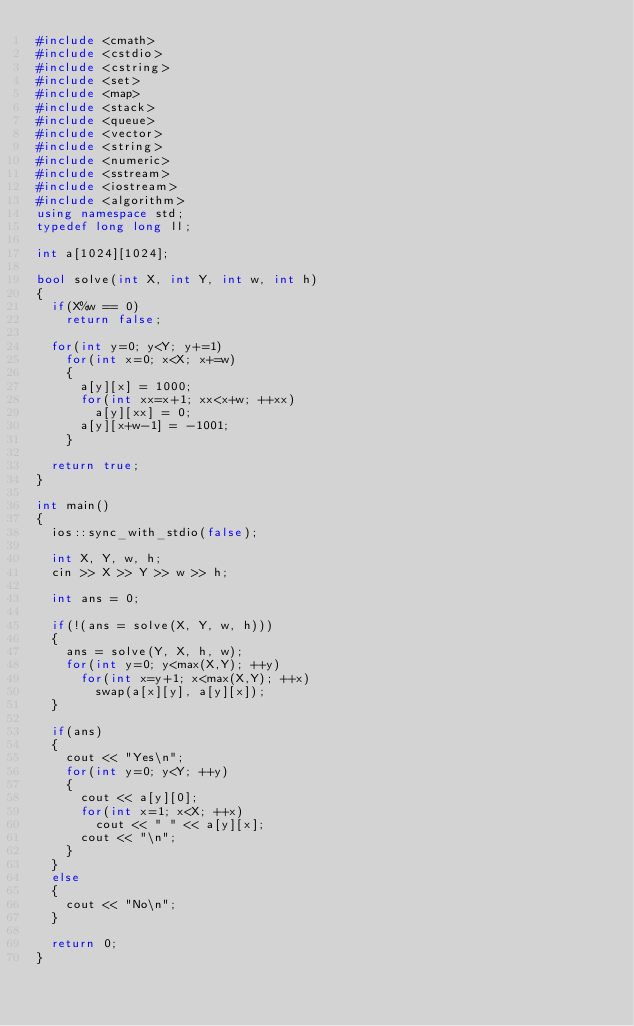<code> <loc_0><loc_0><loc_500><loc_500><_C++_>#include <cmath>
#include <cstdio>
#include <cstring>
#include <set>
#include <map>
#include <stack>
#include <queue>
#include <vector>
#include <string>
#include <numeric>
#include <sstream>
#include <iostream>
#include <algorithm>
using namespace std;
typedef long long ll;

int a[1024][1024];

bool solve(int X, int Y, int w, int h)
{
	if(X%w == 0)
		return false;
	
	for(int y=0; y<Y; y+=1)
		for(int x=0; x<X; x+=w)
		{
			a[y][x] = 1000;
			for(int xx=x+1; xx<x+w; ++xx)
				a[y][xx] = 0;
			a[y][x+w-1] = -1001;
		}
	
	return true;
}

int main()
{
	ios::sync_with_stdio(false);

	int X, Y, w, h;
	cin >> X >> Y >> w >> h;

	int ans = 0;
	
	if(!(ans = solve(X, Y, w, h)))
	{
		ans = solve(Y, X, h, w);
		for(int y=0; y<max(X,Y); ++y)
			for(int x=y+1; x<max(X,Y); ++x)
				swap(a[x][y], a[y][x]);
	}
	
	if(ans)
	{
		cout << "Yes\n";
		for(int y=0; y<Y; ++y)
		{
			cout << a[y][0];
			for(int x=1; x<X; ++x)
				cout << " " << a[y][x];
			cout << "\n";
		}
	}
	else
	{
		cout << "No\n";
	}

	return 0;
}
</code> 